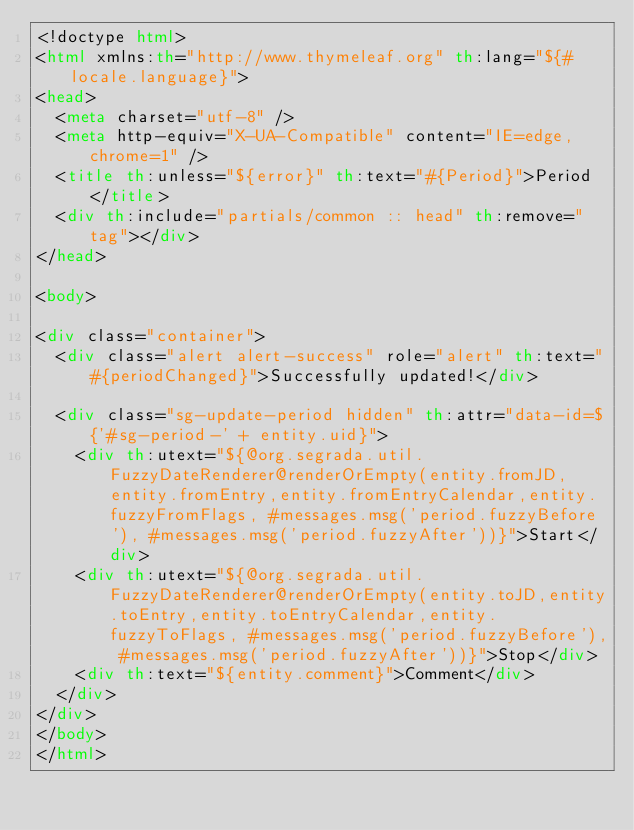<code> <loc_0><loc_0><loc_500><loc_500><_HTML_><!doctype html>
<html xmlns:th="http://www.thymeleaf.org" th:lang="${#locale.language}">
<head>
	<meta charset="utf-8" />
	<meta http-equiv="X-UA-Compatible" content="IE=edge,chrome=1" />
	<title th:unless="${error}" th:text="#{Period}">Period</title>
	<div th:include="partials/common :: head" th:remove="tag"></div>
</head>

<body>

<div class="container">
	<div class="alert alert-success" role="alert" th:text="#{periodChanged}">Successfully updated!</div>

	<div class="sg-update-period hidden" th:attr="data-id=${'#sg-period-' + entity.uid}">
		<div th:utext="${@org.segrada.util.FuzzyDateRenderer@renderOrEmpty(entity.fromJD,entity.fromEntry,entity.fromEntryCalendar,entity.fuzzyFromFlags, #messages.msg('period.fuzzyBefore'), #messages.msg('period.fuzzyAfter'))}">Start</div>
		<div th:utext="${@org.segrada.util.FuzzyDateRenderer@renderOrEmpty(entity.toJD,entity.toEntry,entity.toEntryCalendar,entity.fuzzyToFlags, #messages.msg('period.fuzzyBefore'), #messages.msg('period.fuzzyAfter'))}">Stop</div>
		<div th:text="${entity.comment}">Comment</div>
	</div>
</div>
</body>
</html></code> 